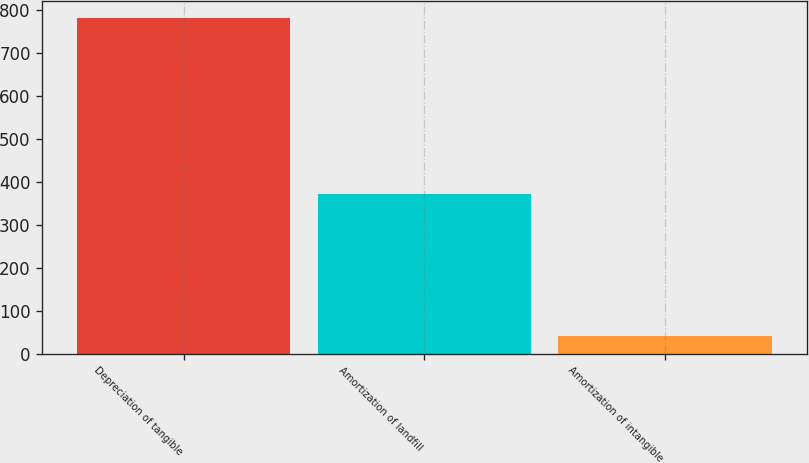<chart> <loc_0><loc_0><loc_500><loc_500><bar_chart><fcel>Depreciation of tangible<fcel>Amortization of landfill<fcel>Amortization of intangible<nl><fcel>781<fcel>372<fcel>41<nl></chart> 